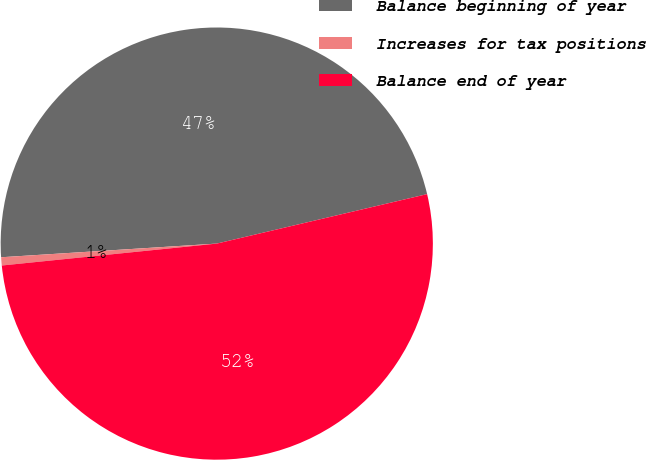Convert chart. <chart><loc_0><loc_0><loc_500><loc_500><pie_chart><fcel>Balance beginning of year<fcel>Increases for tax positions<fcel>Balance end of year<nl><fcel>47.33%<fcel>0.61%<fcel>52.06%<nl></chart> 